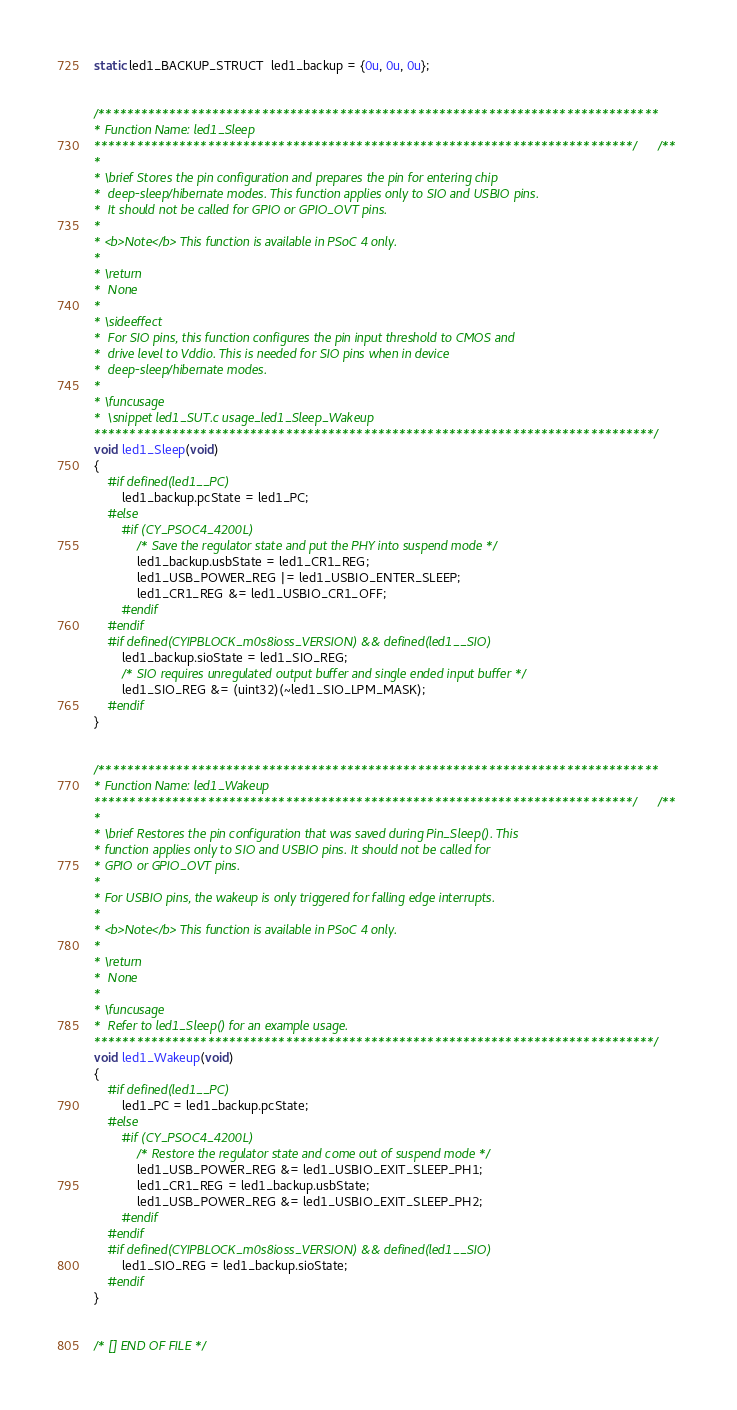<code> <loc_0><loc_0><loc_500><loc_500><_C_>static led1_BACKUP_STRUCT  led1_backup = {0u, 0u, 0u};


/*******************************************************************************
* Function Name: led1_Sleep
****************************************************************************//**
*
* \brief Stores the pin configuration and prepares the pin for entering chip 
*  deep-sleep/hibernate modes. This function applies only to SIO and USBIO pins.
*  It should not be called for GPIO or GPIO_OVT pins.
*
* <b>Note</b> This function is available in PSoC 4 only.
*
* \return 
*  None 
*  
* \sideeffect
*  For SIO pins, this function configures the pin input threshold to CMOS and
*  drive level to Vddio. This is needed for SIO pins when in device 
*  deep-sleep/hibernate modes.
*
* \funcusage
*  \snippet led1_SUT.c usage_led1_Sleep_Wakeup
*******************************************************************************/
void led1_Sleep(void)
{
    #if defined(led1__PC)
        led1_backup.pcState = led1_PC;
    #else
        #if (CY_PSOC4_4200L)
            /* Save the regulator state and put the PHY into suspend mode */
            led1_backup.usbState = led1_CR1_REG;
            led1_USB_POWER_REG |= led1_USBIO_ENTER_SLEEP;
            led1_CR1_REG &= led1_USBIO_CR1_OFF;
        #endif
    #endif
    #if defined(CYIPBLOCK_m0s8ioss_VERSION) && defined(led1__SIO)
        led1_backup.sioState = led1_SIO_REG;
        /* SIO requires unregulated output buffer and single ended input buffer */
        led1_SIO_REG &= (uint32)(~led1_SIO_LPM_MASK);
    #endif  
}


/*******************************************************************************
* Function Name: led1_Wakeup
****************************************************************************//**
*
* \brief Restores the pin configuration that was saved during Pin_Sleep(). This 
* function applies only to SIO and USBIO pins. It should not be called for
* GPIO or GPIO_OVT pins.
*
* For USBIO pins, the wakeup is only triggered for falling edge interrupts.
*
* <b>Note</b> This function is available in PSoC 4 only.
*
* \return 
*  None
*  
* \funcusage
*  Refer to led1_Sleep() for an example usage.
*******************************************************************************/
void led1_Wakeup(void)
{
    #if defined(led1__PC)
        led1_PC = led1_backup.pcState;
    #else
        #if (CY_PSOC4_4200L)
            /* Restore the regulator state and come out of suspend mode */
            led1_USB_POWER_REG &= led1_USBIO_EXIT_SLEEP_PH1;
            led1_CR1_REG = led1_backup.usbState;
            led1_USB_POWER_REG &= led1_USBIO_EXIT_SLEEP_PH2;
        #endif
    #endif
    #if defined(CYIPBLOCK_m0s8ioss_VERSION) && defined(led1__SIO)
        led1_SIO_REG = led1_backup.sioState;
    #endif
}


/* [] END OF FILE */
</code> 